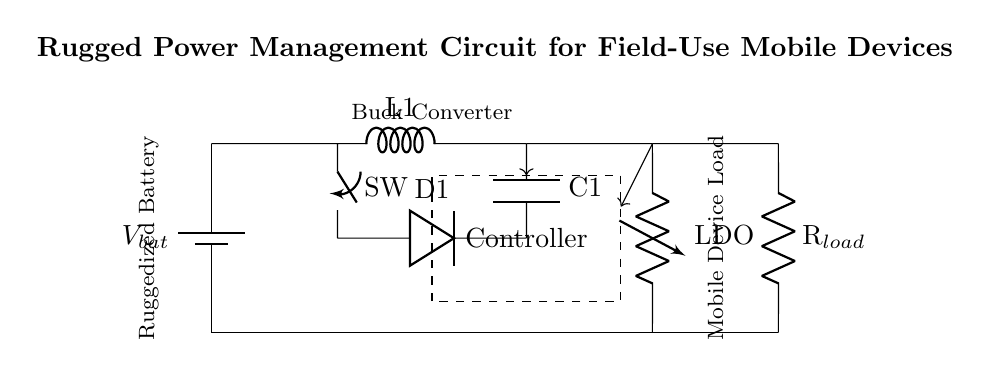What is the main source of power in this circuit? The main source of power is the battery, represented as V_bat, which provides the necessary voltage for the circuit operation.
Answer: battery What component regulates the voltage for the load? The voltage regulator, labeled as LDO, is responsible for regulating the voltage supplied to the load from the output of the buck converter, ensuring the load receives stable voltage.
Answer: LDO What type of converter is used in this circuit? The circuit uses a buck converter, indicated by the labeled section in the diagram, which steps down the voltage from the battery to a lower level that can be used by the load.
Answer: buck converter How many feedback lines are present in this circuit? There are two feedback lines in the circuit, as shown by the arrows leading from the output of the sections (buck converter and voltage regulator) towards the controller.
Answer: two Which component offers protection against reverse current? The component protecting against reverse current is the diode, labeled as D1, which allows current to flow in one direction and prevents backflow that could damage the circuit.
Answer: diode What element is responsible for storing energy in the circuit? The inductor, labeled as L1, is responsible for storing energy in the circuit during the operation of the buck converter, functioning as a key element in energy management.
Answer: inductor 